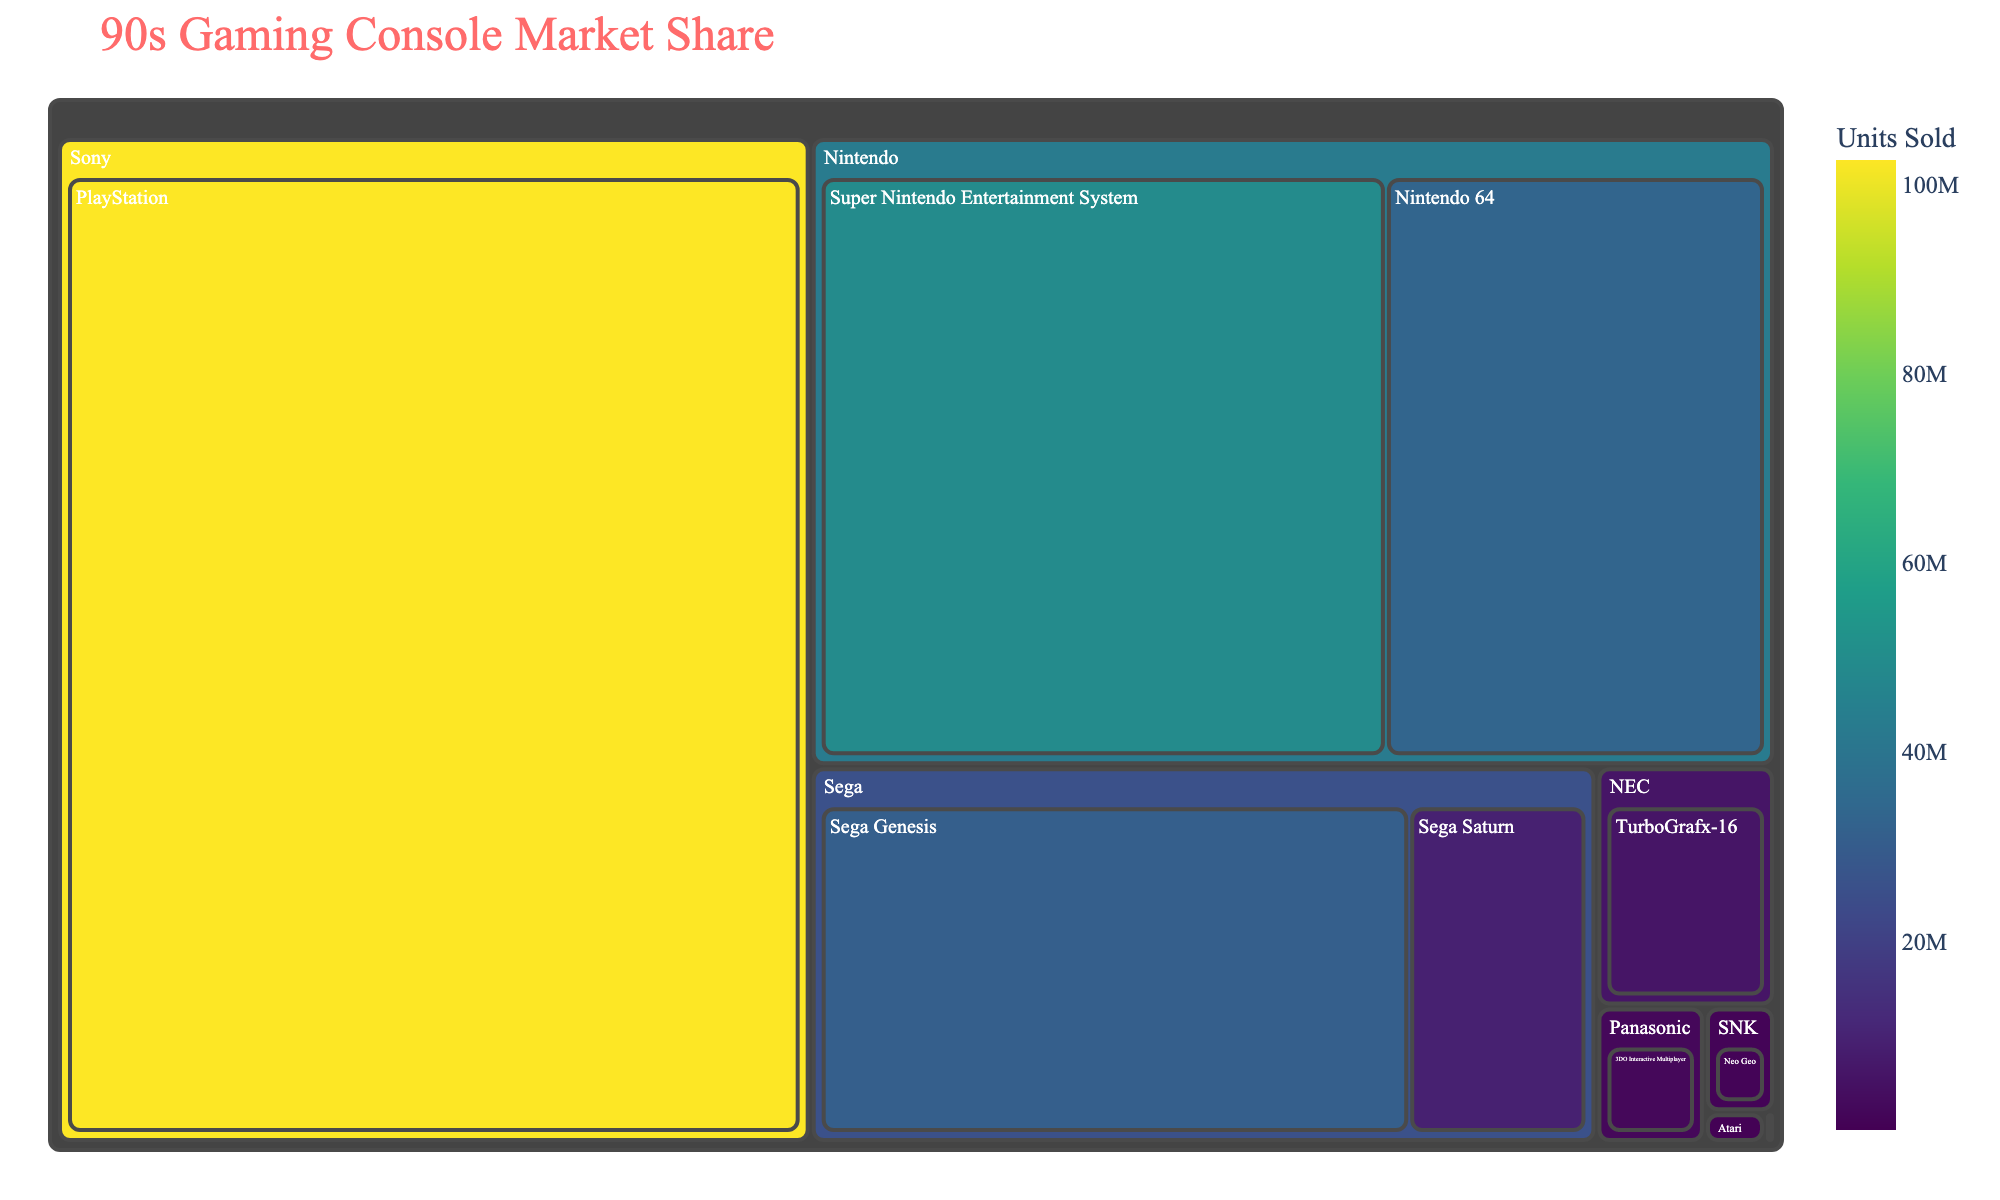Which gaming console has the highest market share on the treemap? By examining the size of the boxes, the console with the largest area is identifiable. The largest box belongs to Sony's PlayStation.
Answer: PlayStation How many units did Sega Saturn sell? By hovering over Sega Saturn's section on the treemap, the details on the units sold can be found. Sega Saturn sold 9,260,000 units.
Answer: 9,260,000 What's the total units sold for Nintendo's consoles combined? Locate Nintendo's section on the treemap and add up the units sold for both Super Nintendo Entertainment System (49,100,000) and Nintendo 64 (32,930,000). The total is 49,100,000 + 32,930,000 = 82,030,000 units.
Answer: 82,030,000 Which manufacturer has the smallest market share in terms of units sold? Identify the smallest box in the treemap, which would be Bandai's Pippin with only 42,000 units sold.
Answer: Bandai How does Sega Genesis's units sold compare to TurboGrafx-16? Check the respective boxes for Sega Genesis and TurboGrafx-16, then compare their units sold. Sega Genesis sold 30,750,000 units, while TurboGrafx-16 sold 5,800,000 units. Sega Genesis sold significantly more.
Answer: Sega Genesis sold more than TurboGrafx-16 What's the difference in units sold between Nintendo 64 and Sega Genesis? Subtract the units sold of Sega Genesis from those of Nintendo 64: 32,930,000 - 30,750,000 = 2,180,000 units.
Answer: 2,180,000 units Which manufacturers produced only one gaming console featured in the treemap? By observing the treemap, manufacturers with a single box can be identified: Atari (Atari Jaguar), NEC (TurboGrafx-16), SNK (Neo Geo), Panasonic (3DO Interactive Multiplayer), and Bandai (Pippin).
Answer: Atari, NEC, SNK, Panasonic, Bandai How does the market share of 3DO Interactive Multiplayer compare to Neo Geo? By examining their respective sections in the treemap, compare the number of units sold. 3DO Interactive Multiplayer sold 2,000,000 units, while Neo Geo sold 1,000,000 units. 3DO Interactive Multiplayer sold more.
Answer: 3DO Interactive Multiplayer sold more than Neo Geo What's the combined market share of all Sega consoles in units sold? Add up the units sold for Sega Genesis (30,750,000) and Sega Saturn (9,260,000): 30,750,000 + 9,260,000 = 40,010,000 units.
Answer: 40,010,000 units What's the total number of units sold for all consoles in the treemap? Sum the units sold for all consoles: 49,100,000 (SNES) + 32,930,000 (N64) + 30,750,000 (Sega Genesis) + 102,490,000 (PlayStation) + 9,260,000 (Sega Saturn) + 250,000 (Atari Jaguar) + 5,800,000 (TurboGrafx-16) + 1,000,000 (Neo Geo) + 2,000,000 (3DO) + 42,000 (Pippin) = 233,622,000 units.
Answer: 233,622,000 units 